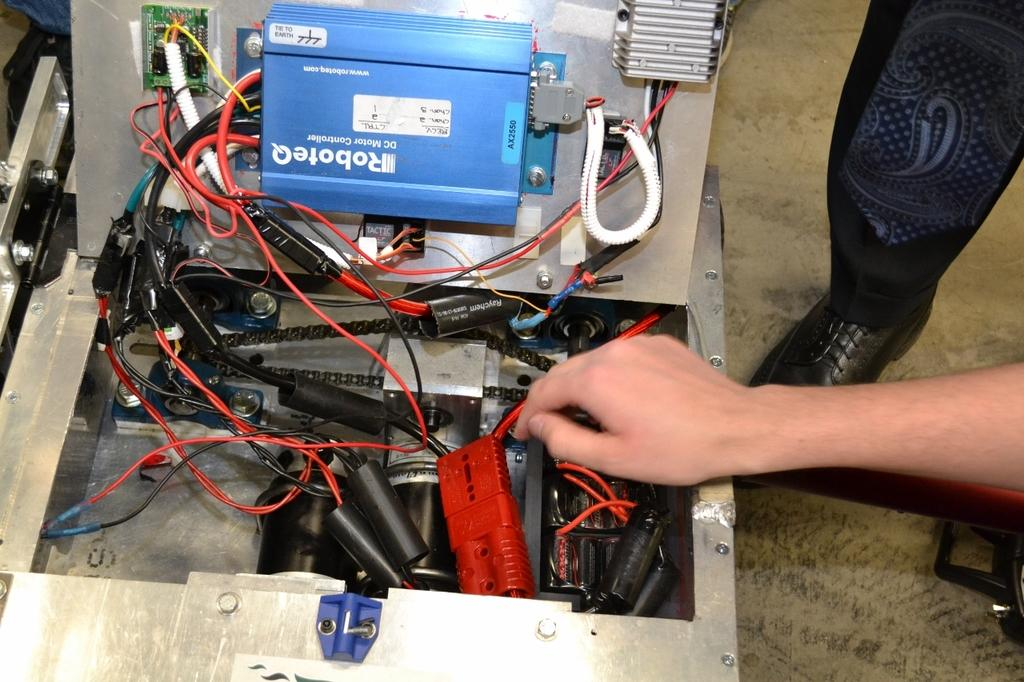What is the hand in the image touching? The hand in the image is touching an electrical device. What are some features of the electrical device? The electrical device has cables and circuit boards in the image. What can be seen on the right side of the image? There is a leg on the right side of the image. What type of books are being used to decorate the cakes in the image? There are no books or cakes present in the image; it features a hand on an electrical device and a leg on the right side. 